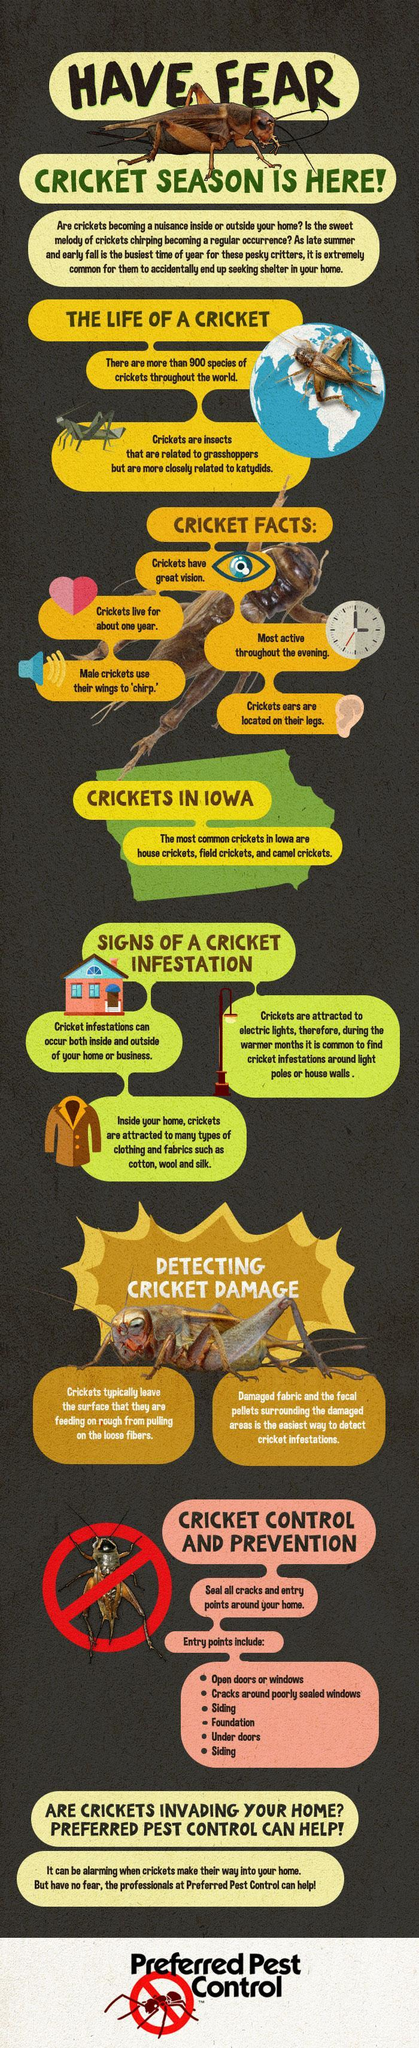Which is the fourth entry point mentioned in this infographic?
Answer the question with a short phrase. Foundation How many types of crickets found in Iowa? 3 How many entries are mentioned in this infographic? 6 Crickets are attracted to how many types of fabric mentioned in this infographic? 3 What is the lifespan of Cricket? about one year Which gender cricket uses their wings to chirp-female, male? male 